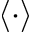Convert formula to latex. <formula><loc_0><loc_0><loc_500><loc_500>\langle \cdot \rangle</formula> 